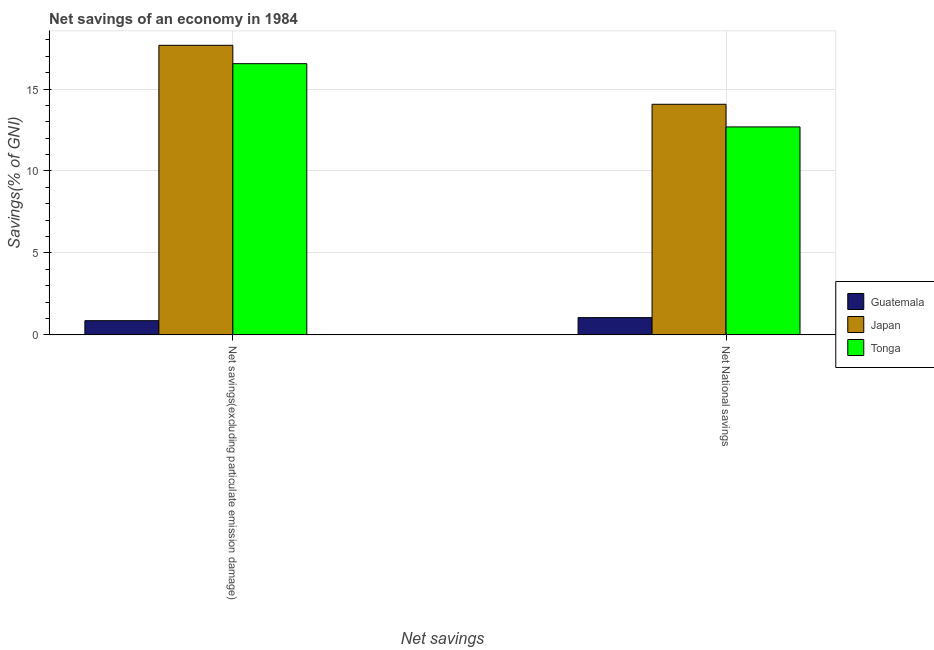How many different coloured bars are there?
Provide a short and direct response. 3. Are the number of bars on each tick of the X-axis equal?
Provide a succinct answer. Yes. What is the label of the 2nd group of bars from the left?
Keep it short and to the point. Net National savings. What is the net national savings in Japan?
Provide a short and direct response. 14.07. Across all countries, what is the maximum net savings(excluding particulate emission damage)?
Offer a terse response. 17.67. Across all countries, what is the minimum net savings(excluding particulate emission damage)?
Provide a short and direct response. 0.87. In which country was the net national savings maximum?
Give a very brief answer. Japan. In which country was the net national savings minimum?
Offer a terse response. Guatemala. What is the total net national savings in the graph?
Offer a very short reply. 27.82. What is the difference between the net national savings in Guatemala and that in Japan?
Your answer should be very brief. -13.02. What is the difference between the net national savings in Tonga and the net savings(excluding particulate emission damage) in Japan?
Make the answer very short. -4.98. What is the average net national savings per country?
Your answer should be very brief. 9.27. What is the difference between the net national savings and net savings(excluding particulate emission damage) in Guatemala?
Provide a short and direct response. 0.19. In how many countries, is the net savings(excluding particulate emission damage) greater than 9 %?
Offer a terse response. 2. What is the ratio of the net national savings in Guatemala to that in Japan?
Your response must be concise. 0.07. Is the net national savings in Tonga less than that in Guatemala?
Provide a succinct answer. No. What does the 2nd bar from the left in Net savings(excluding particulate emission damage) represents?
Your answer should be very brief. Japan. How many bars are there?
Your answer should be very brief. 6. Are the values on the major ticks of Y-axis written in scientific E-notation?
Provide a succinct answer. No. Does the graph contain any zero values?
Your answer should be compact. No. Does the graph contain grids?
Your response must be concise. Yes. Where does the legend appear in the graph?
Make the answer very short. Center right. How many legend labels are there?
Give a very brief answer. 3. What is the title of the graph?
Your answer should be compact. Net savings of an economy in 1984. Does "Middle income" appear as one of the legend labels in the graph?
Make the answer very short. No. What is the label or title of the X-axis?
Your answer should be very brief. Net savings. What is the label or title of the Y-axis?
Offer a very short reply. Savings(% of GNI). What is the Savings(% of GNI) of Guatemala in Net savings(excluding particulate emission damage)?
Make the answer very short. 0.87. What is the Savings(% of GNI) in Japan in Net savings(excluding particulate emission damage)?
Your answer should be very brief. 17.67. What is the Savings(% of GNI) in Tonga in Net savings(excluding particulate emission damage)?
Your answer should be compact. 16.55. What is the Savings(% of GNI) of Guatemala in Net National savings?
Provide a short and direct response. 1.05. What is the Savings(% of GNI) of Japan in Net National savings?
Offer a terse response. 14.07. What is the Savings(% of GNI) in Tonga in Net National savings?
Give a very brief answer. 12.69. Across all Net savings, what is the maximum Savings(% of GNI) of Guatemala?
Offer a very short reply. 1.05. Across all Net savings, what is the maximum Savings(% of GNI) of Japan?
Ensure brevity in your answer.  17.67. Across all Net savings, what is the maximum Savings(% of GNI) in Tonga?
Ensure brevity in your answer.  16.55. Across all Net savings, what is the minimum Savings(% of GNI) in Guatemala?
Offer a terse response. 0.87. Across all Net savings, what is the minimum Savings(% of GNI) of Japan?
Provide a succinct answer. 14.07. Across all Net savings, what is the minimum Savings(% of GNI) of Tonga?
Ensure brevity in your answer.  12.69. What is the total Savings(% of GNI) in Guatemala in the graph?
Your answer should be compact. 1.92. What is the total Savings(% of GNI) in Japan in the graph?
Offer a terse response. 31.74. What is the total Savings(% of GNI) in Tonga in the graph?
Provide a short and direct response. 29.24. What is the difference between the Savings(% of GNI) in Guatemala in Net savings(excluding particulate emission damage) and that in Net National savings?
Offer a very short reply. -0.19. What is the difference between the Savings(% of GNI) of Japan in Net savings(excluding particulate emission damage) and that in Net National savings?
Keep it short and to the point. 3.6. What is the difference between the Savings(% of GNI) in Tonga in Net savings(excluding particulate emission damage) and that in Net National savings?
Give a very brief answer. 3.86. What is the difference between the Savings(% of GNI) in Guatemala in Net savings(excluding particulate emission damage) and the Savings(% of GNI) in Japan in Net National savings?
Offer a very short reply. -13.2. What is the difference between the Savings(% of GNI) of Guatemala in Net savings(excluding particulate emission damage) and the Savings(% of GNI) of Tonga in Net National savings?
Make the answer very short. -11.82. What is the difference between the Savings(% of GNI) in Japan in Net savings(excluding particulate emission damage) and the Savings(% of GNI) in Tonga in Net National savings?
Your answer should be compact. 4.98. What is the average Savings(% of GNI) in Guatemala per Net savings?
Offer a terse response. 0.96. What is the average Savings(% of GNI) in Japan per Net savings?
Offer a very short reply. 15.87. What is the average Savings(% of GNI) of Tonga per Net savings?
Make the answer very short. 14.62. What is the difference between the Savings(% of GNI) in Guatemala and Savings(% of GNI) in Japan in Net savings(excluding particulate emission damage)?
Provide a short and direct response. -16.8. What is the difference between the Savings(% of GNI) of Guatemala and Savings(% of GNI) of Tonga in Net savings(excluding particulate emission damage)?
Offer a terse response. -15.68. What is the difference between the Savings(% of GNI) of Japan and Savings(% of GNI) of Tonga in Net savings(excluding particulate emission damage)?
Make the answer very short. 1.12. What is the difference between the Savings(% of GNI) of Guatemala and Savings(% of GNI) of Japan in Net National savings?
Offer a very short reply. -13.02. What is the difference between the Savings(% of GNI) in Guatemala and Savings(% of GNI) in Tonga in Net National savings?
Your answer should be very brief. -11.64. What is the difference between the Savings(% of GNI) of Japan and Savings(% of GNI) of Tonga in Net National savings?
Offer a very short reply. 1.38. What is the ratio of the Savings(% of GNI) of Guatemala in Net savings(excluding particulate emission damage) to that in Net National savings?
Provide a short and direct response. 0.82. What is the ratio of the Savings(% of GNI) in Japan in Net savings(excluding particulate emission damage) to that in Net National savings?
Your answer should be compact. 1.26. What is the ratio of the Savings(% of GNI) in Tonga in Net savings(excluding particulate emission damage) to that in Net National savings?
Provide a succinct answer. 1.3. What is the difference between the highest and the second highest Savings(% of GNI) in Guatemala?
Offer a terse response. 0.19. What is the difference between the highest and the second highest Savings(% of GNI) of Japan?
Make the answer very short. 3.6. What is the difference between the highest and the second highest Savings(% of GNI) in Tonga?
Offer a very short reply. 3.86. What is the difference between the highest and the lowest Savings(% of GNI) in Guatemala?
Provide a short and direct response. 0.19. What is the difference between the highest and the lowest Savings(% of GNI) in Japan?
Your answer should be very brief. 3.6. What is the difference between the highest and the lowest Savings(% of GNI) of Tonga?
Keep it short and to the point. 3.86. 